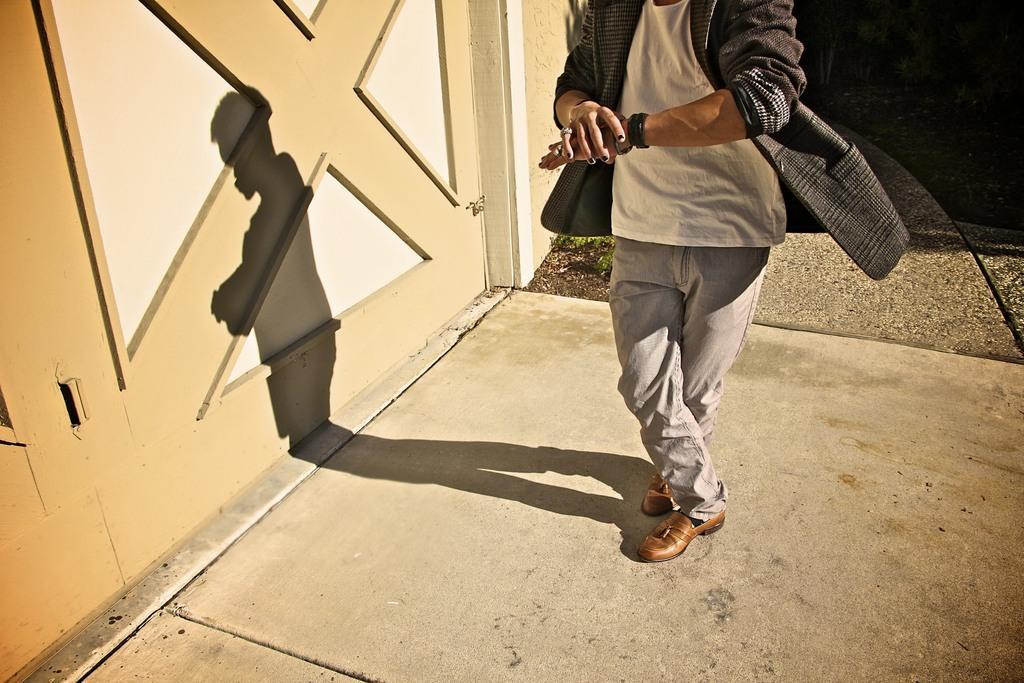Please provide a concise description of this image. This image is taken outdoors. At the bottom of the image there is a floor. On the left side of the image there is a wall. In the middle of the image there is a man. 